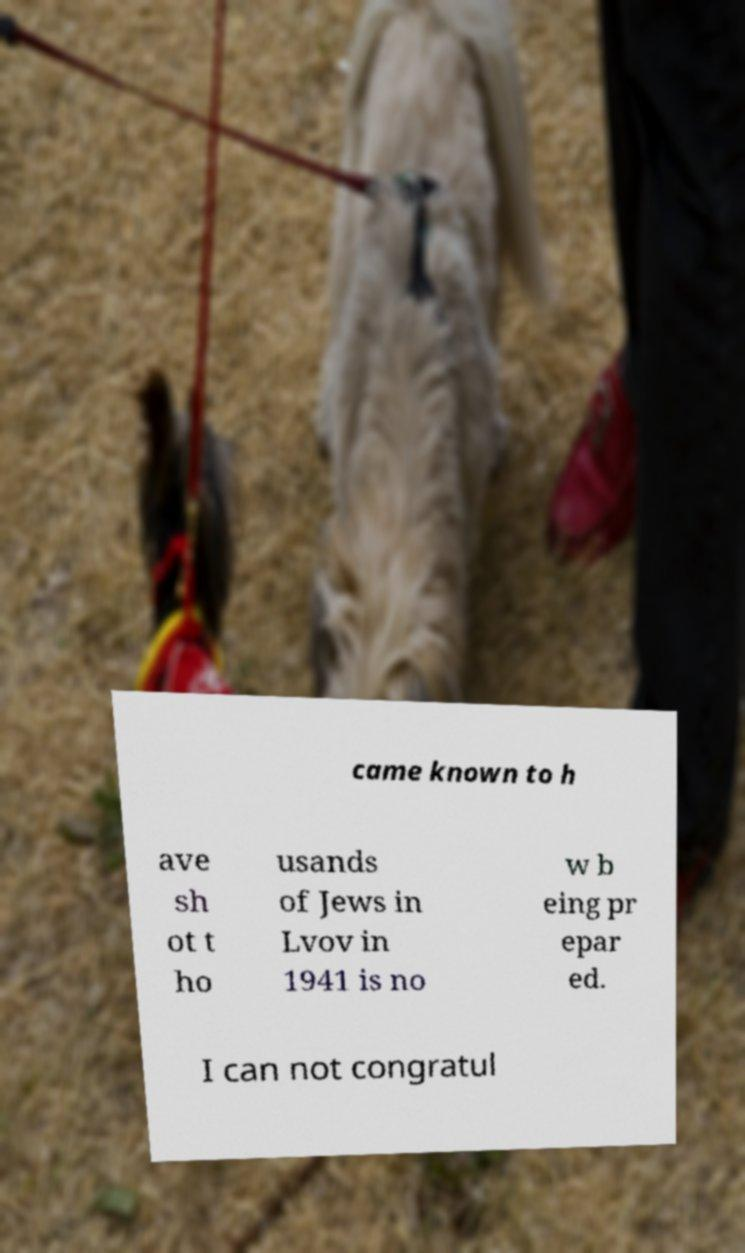Could you assist in decoding the text presented in this image and type it out clearly? came known to h ave sh ot t ho usands of Jews in Lvov in 1941 is no w b eing pr epar ed. I can not congratul 